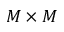<formula> <loc_0><loc_0><loc_500><loc_500>M \times M</formula> 